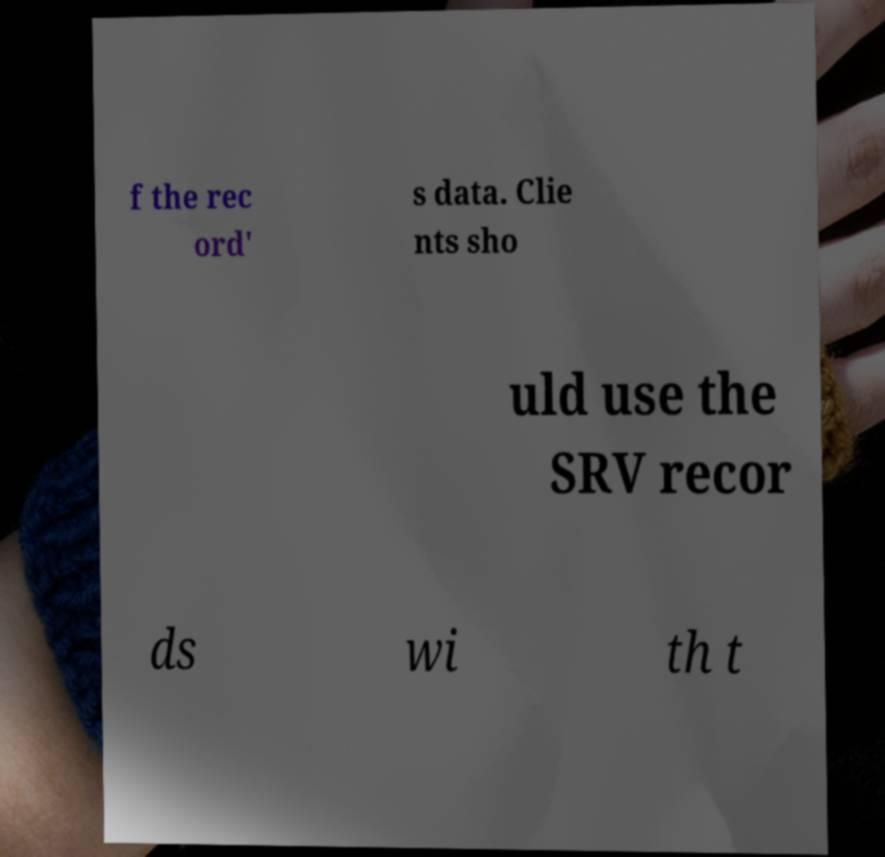I need the written content from this picture converted into text. Can you do that? f the rec ord' s data. Clie nts sho uld use the SRV recor ds wi th t 